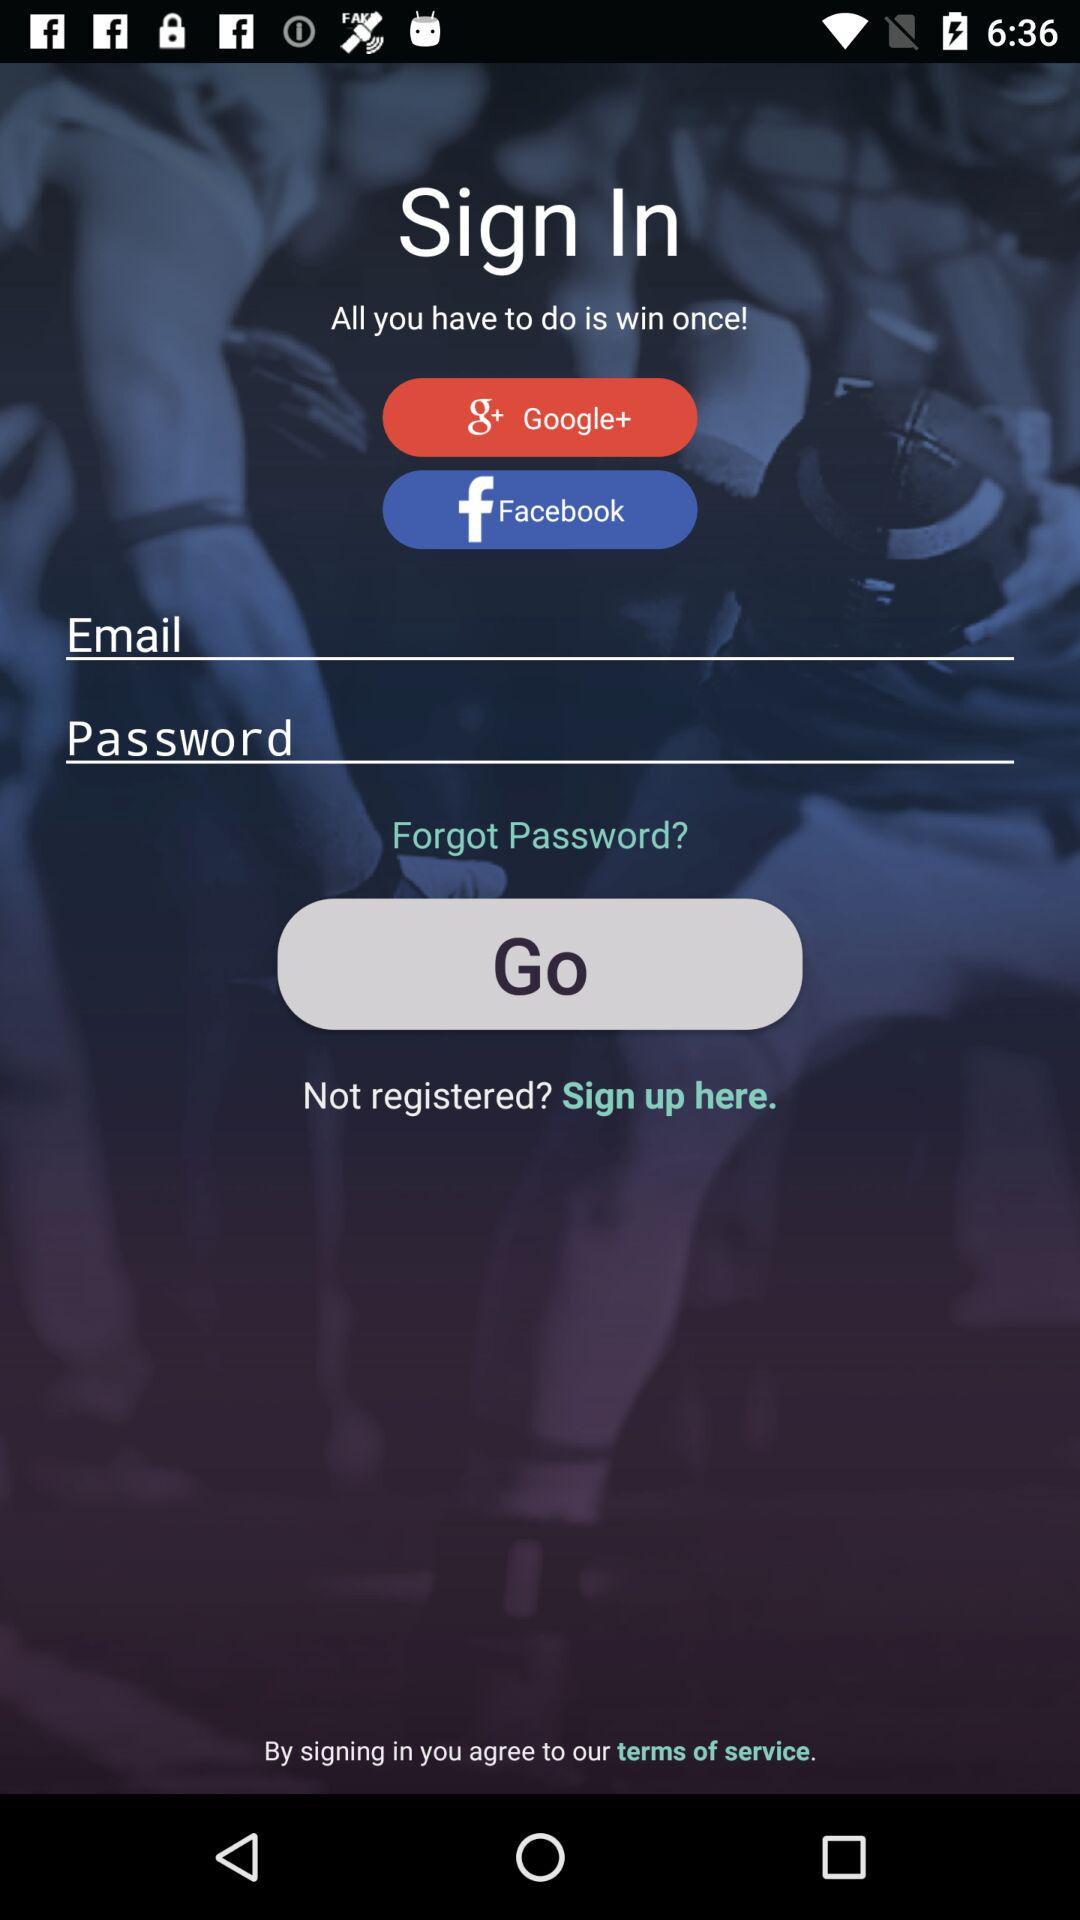What are the alternative choices for signing in? The alternative choices for signing in are "Google+" and "Facebook". 